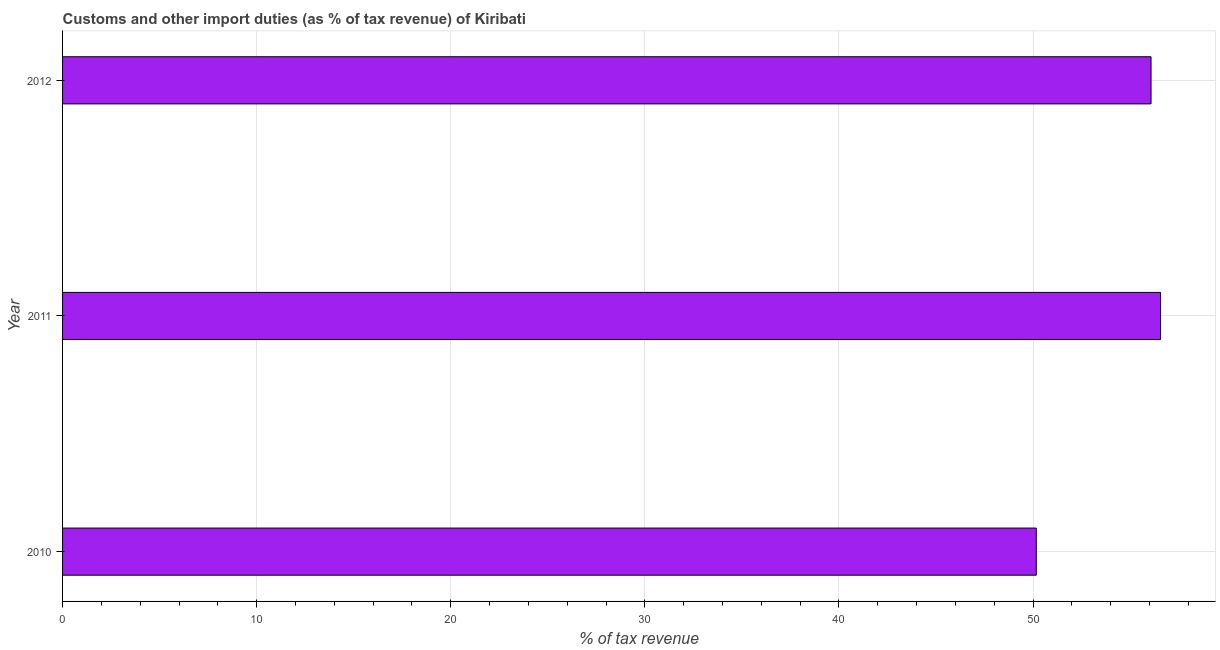Does the graph contain any zero values?
Keep it short and to the point. No. What is the title of the graph?
Make the answer very short. Customs and other import duties (as % of tax revenue) of Kiribati. What is the label or title of the X-axis?
Keep it short and to the point. % of tax revenue. What is the label or title of the Y-axis?
Make the answer very short. Year. What is the customs and other import duties in 2012?
Provide a succinct answer. 56.08. Across all years, what is the maximum customs and other import duties?
Offer a terse response. 56.57. Across all years, what is the minimum customs and other import duties?
Your answer should be compact. 50.17. In which year was the customs and other import duties maximum?
Offer a very short reply. 2011. In which year was the customs and other import duties minimum?
Make the answer very short. 2010. What is the sum of the customs and other import duties?
Provide a succinct answer. 162.81. What is the difference between the customs and other import duties in 2010 and 2011?
Ensure brevity in your answer.  -6.41. What is the average customs and other import duties per year?
Offer a terse response. 54.27. What is the median customs and other import duties?
Provide a succinct answer. 56.08. In how many years, is the customs and other import duties greater than 56 %?
Provide a succinct answer. 2. Do a majority of the years between 2011 and 2012 (inclusive) have customs and other import duties greater than 28 %?
Give a very brief answer. Yes. Is the difference between the customs and other import duties in 2011 and 2012 greater than the difference between any two years?
Ensure brevity in your answer.  No. What is the difference between the highest and the second highest customs and other import duties?
Ensure brevity in your answer.  0.49. In how many years, is the customs and other import duties greater than the average customs and other import duties taken over all years?
Make the answer very short. 2. How many years are there in the graph?
Make the answer very short. 3. Are the values on the major ticks of X-axis written in scientific E-notation?
Provide a short and direct response. No. What is the % of tax revenue in 2010?
Your answer should be very brief. 50.17. What is the % of tax revenue in 2011?
Keep it short and to the point. 56.57. What is the % of tax revenue in 2012?
Your answer should be compact. 56.08. What is the difference between the % of tax revenue in 2010 and 2011?
Offer a very short reply. -6.4. What is the difference between the % of tax revenue in 2010 and 2012?
Provide a succinct answer. -5.91. What is the difference between the % of tax revenue in 2011 and 2012?
Give a very brief answer. 0.49. What is the ratio of the % of tax revenue in 2010 to that in 2011?
Provide a succinct answer. 0.89. What is the ratio of the % of tax revenue in 2010 to that in 2012?
Your response must be concise. 0.9. What is the ratio of the % of tax revenue in 2011 to that in 2012?
Your answer should be very brief. 1.01. 